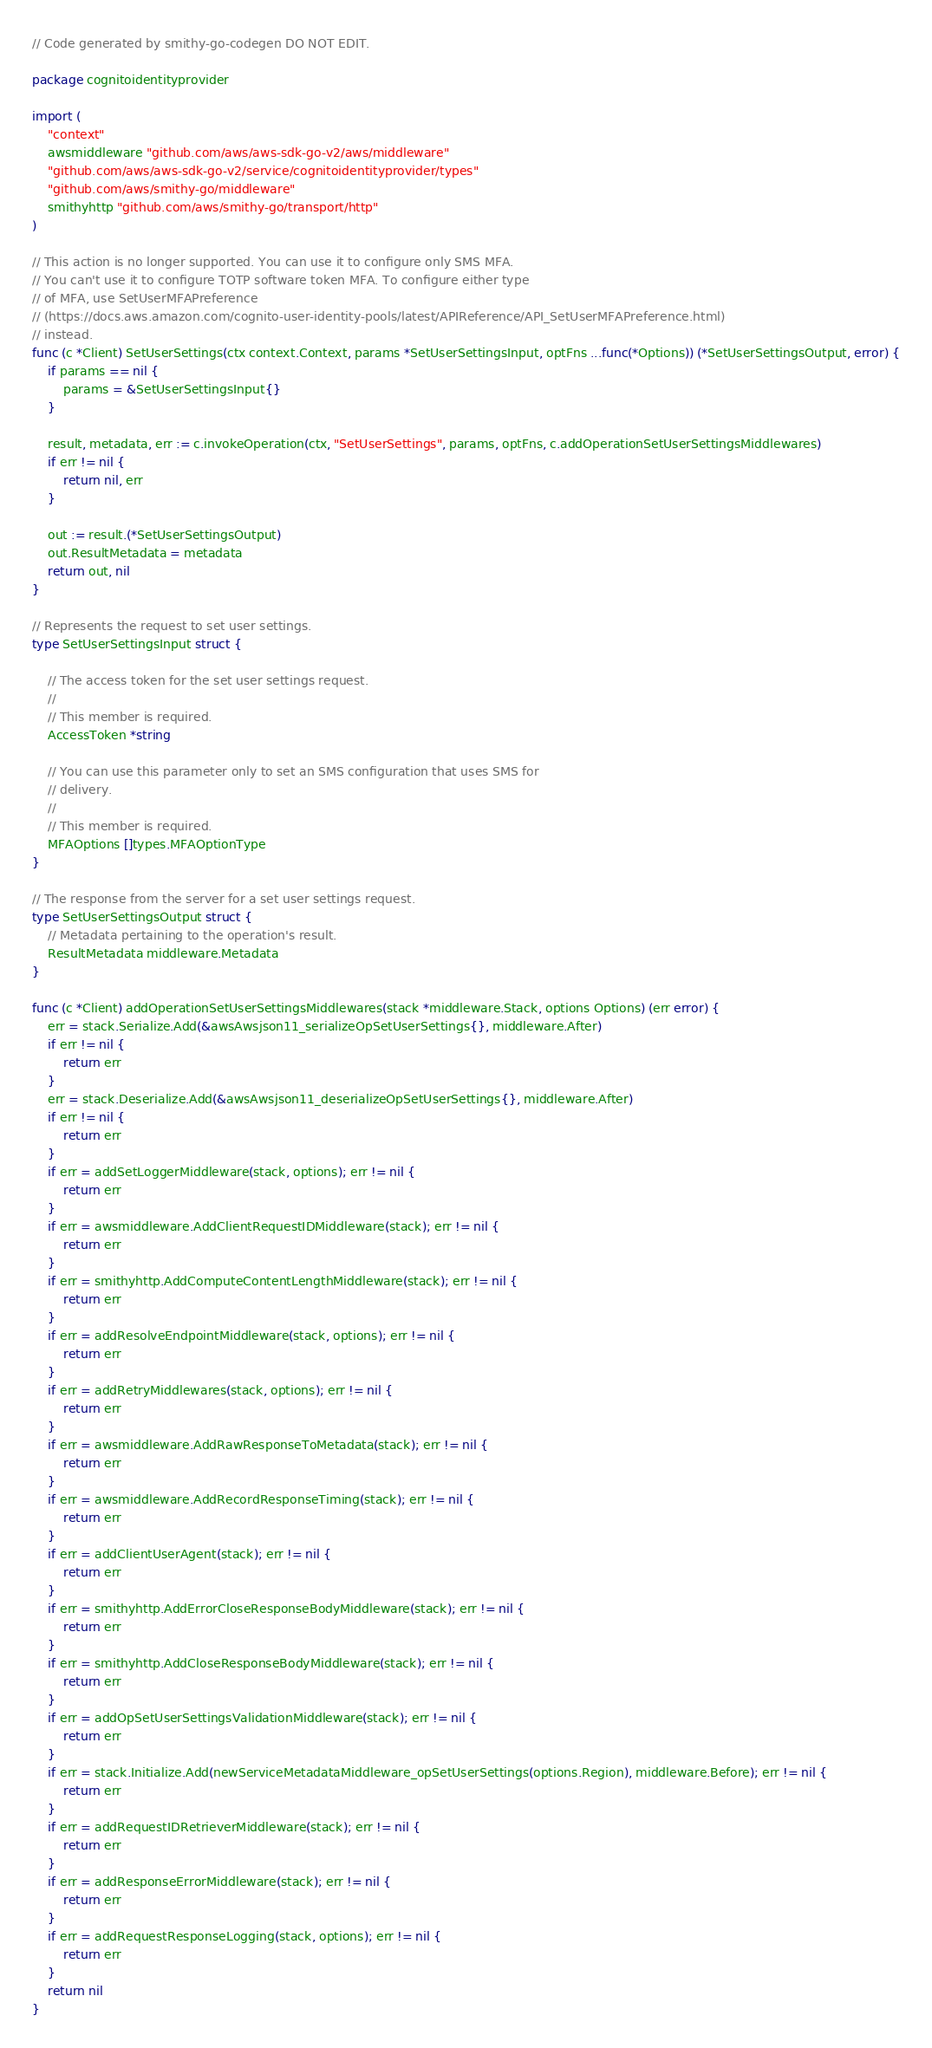Convert code to text. <code><loc_0><loc_0><loc_500><loc_500><_Go_>// Code generated by smithy-go-codegen DO NOT EDIT.

package cognitoidentityprovider

import (
	"context"
	awsmiddleware "github.com/aws/aws-sdk-go-v2/aws/middleware"
	"github.com/aws/aws-sdk-go-v2/service/cognitoidentityprovider/types"
	"github.com/aws/smithy-go/middleware"
	smithyhttp "github.com/aws/smithy-go/transport/http"
)

// This action is no longer supported. You can use it to configure only SMS MFA.
// You can't use it to configure TOTP software token MFA. To configure either type
// of MFA, use SetUserMFAPreference
// (https://docs.aws.amazon.com/cognito-user-identity-pools/latest/APIReference/API_SetUserMFAPreference.html)
// instead.
func (c *Client) SetUserSettings(ctx context.Context, params *SetUserSettingsInput, optFns ...func(*Options)) (*SetUserSettingsOutput, error) {
	if params == nil {
		params = &SetUserSettingsInput{}
	}

	result, metadata, err := c.invokeOperation(ctx, "SetUserSettings", params, optFns, c.addOperationSetUserSettingsMiddlewares)
	if err != nil {
		return nil, err
	}

	out := result.(*SetUserSettingsOutput)
	out.ResultMetadata = metadata
	return out, nil
}

// Represents the request to set user settings.
type SetUserSettingsInput struct {

	// The access token for the set user settings request.
	//
	// This member is required.
	AccessToken *string

	// You can use this parameter only to set an SMS configuration that uses SMS for
	// delivery.
	//
	// This member is required.
	MFAOptions []types.MFAOptionType
}

// The response from the server for a set user settings request.
type SetUserSettingsOutput struct {
	// Metadata pertaining to the operation's result.
	ResultMetadata middleware.Metadata
}

func (c *Client) addOperationSetUserSettingsMiddlewares(stack *middleware.Stack, options Options) (err error) {
	err = stack.Serialize.Add(&awsAwsjson11_serializeOpSetUserSettings{}, middleware.After)
	if err != nil {
		return err
	}
	err = stack.Deserialize.Add(&awsAwsjson11_deserializeOpSetUserSettings{}, middleware.After)
	if err != nil {
		return err
	}
	if err = addSetLoggerMiddleware(stack, options); err != nil {
		return err
	}
	if err = awsmiddleware.AddClientRequestIDMiddleware(stack); err != nil {
		return err
	}
	if err = smithyhttp.AddComputeContentLengthMiddleware(stack); err != nil {
		return err
	}
	if err = addResolveEndpointMiddleware(stack, options); err != nil {
		return err
	}
	if err = addRetryMiddlewares(stack, options); err != nil {
		return err
	}
	if err = awsmiddleware.AddRawResponseToMetadata(stack); err != nil {
		return err
	}
	if err = awsmiddleware.AddRecordResponseTiming(stack); err != nil {
		return err
	}
	if err = addClientUserAgent(stack); err != nil {
		return err
	}
	if err = smithyhttp.AddErrorCloseResponseBodyMiddleware(stack); err != nil {
		return err
	}
	if err = smithyhttp.AddCloseResponseBodyMiddleware(stack); err != nil {
		return err
	}
	if err = addOpSetUserSettingsValidationMiddleware(stack); err != nil {
		return err
	}
	if err = stack.Initialize.Add(newServiceMetadataMiddleware_opSetUserSettings(options.Region), middleware.Before); err != nil {
		return err
	}
	if err = addRequestIDRetrieverMiddleware(stack); err != nil {
		return err
	}
	if err = addResponseErrorMiddleware(stack); err != nil {
		return err
	}
	if err = addRequestResponseLogging(stack, options); err != nil {
		return err
	}
	return nil
}
</code> 